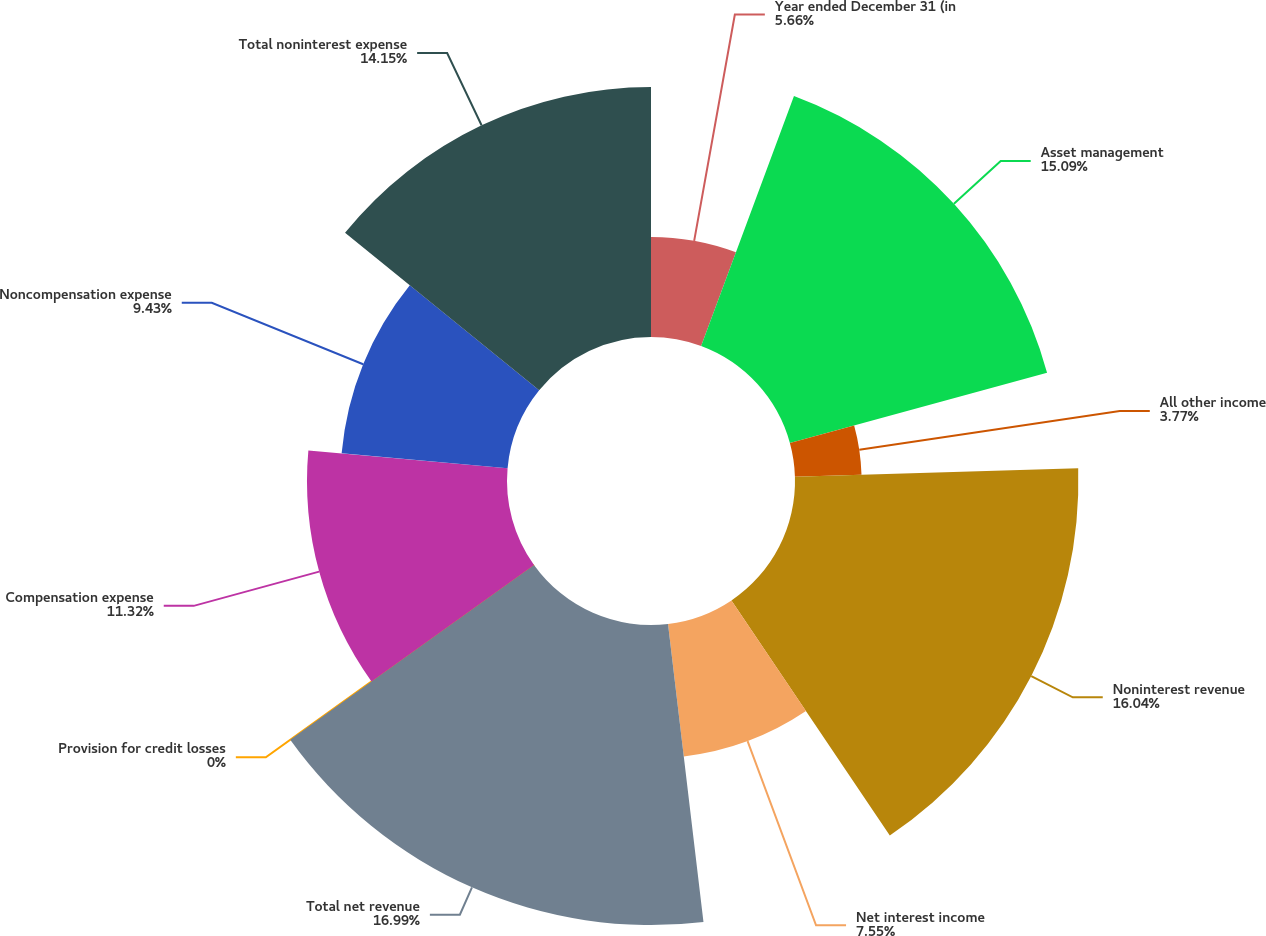Convert chart. <chart><loc_0><loc_0><loc_500><loc_500><pie_chart><fcel>Year ended December 31 (in<fcel>Asset management<fcel>All other income<fcel>Noninterest revenue<fcel>Net interest income<fcel>Total net revenue<fcel>Provision for credit losses<fcel>Compensation expense<fcel>Noncompensation expense<fcel>Total noninterest expense<nl><fcel>5.66%<fcel>15.09%<fcel>3.77%<fcel>16.04%<fcel>7.55%<fcel>16.98%<fcel>0.0%<fcel>11.32%<fcel>9.43%<fcel>14.15%<nl></chart> 